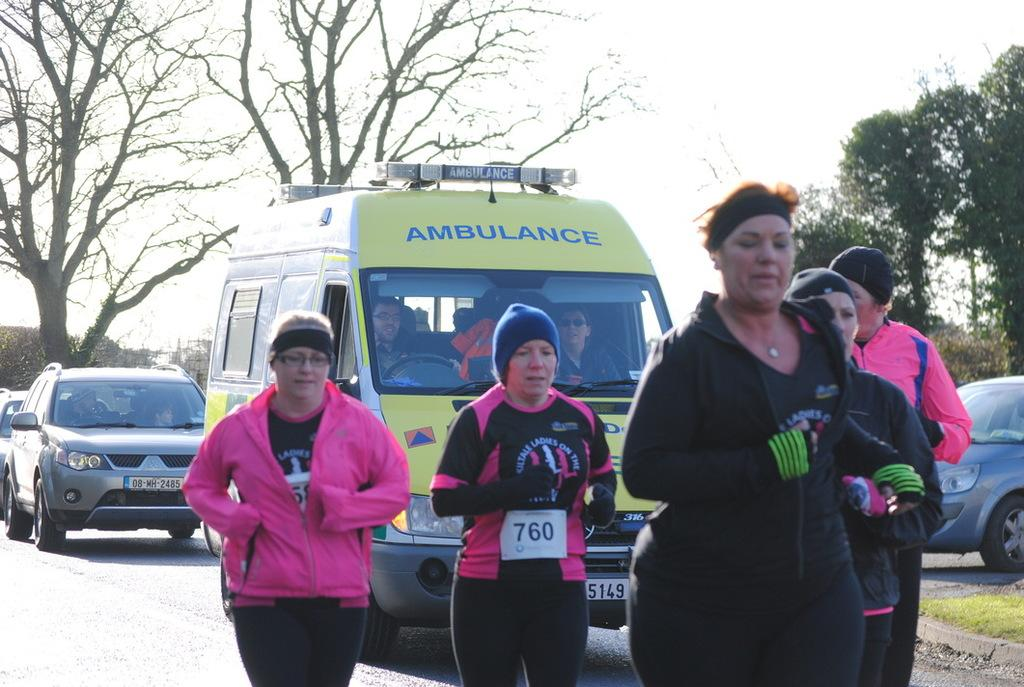What are the women in the image doing? The women in the image are running on the road. What can be seen in the background of the image? In the background, there is an ambulance, cars, trees, and the sky. How many vehicles are visible in the background? There are two vehicles visible in the background, an ambulance and a car. Where is the hen sitting in the image? There is no hen present in the image. What type of airplane can be seen flying in the sky in the image? There is no airplane visible in the sky in the image. 